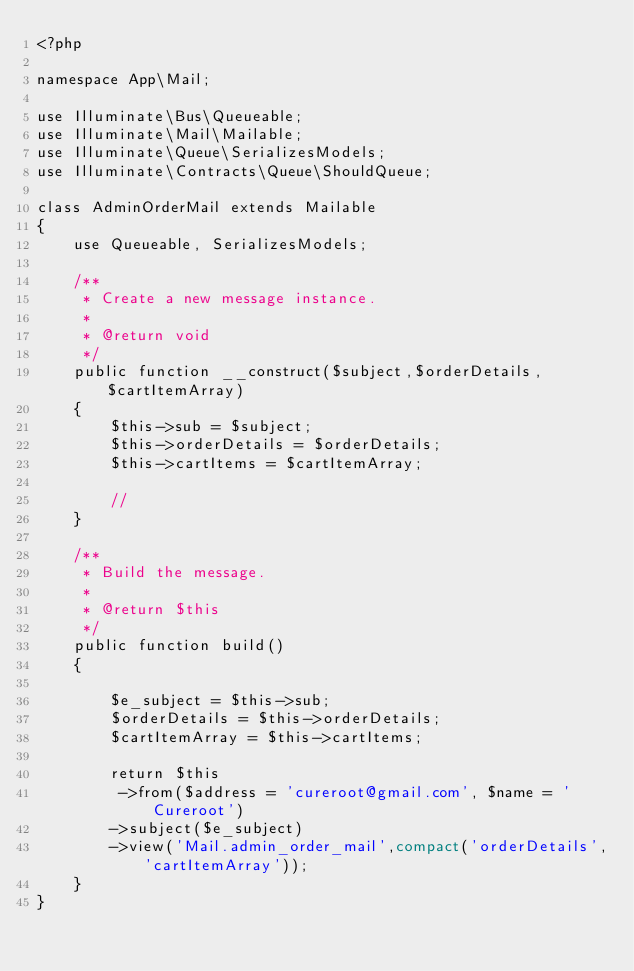Convert code to text. <code><loc_0><loc_0><loc_500><loc_500><_PHP_><?php

namespace App\Mail;

use Illuminate\Bus\Queueable;
use Illuminate\Mail\Mailable;
use Illuminate\Queue\SerializesModels;
use Illuminate\Contracts\Queue\ShouldQueue;

class AdminOrderMail extends Mailable
{
    use Queueable, SerializesModels;

    /**
     * Create a new message instance.
     *
     * @return void
     */
    public function __construct($subject,$orderDetails,$cartItemArray)
    {
        $this->sub = $subject;
        $this->orderDetails = $orderDetails;
        $this->cartItems = $cartItemArray;

        //
    }

    /**
     * Build the message.
     *
     * @return $this
     */
    public function build()
    {
        
        $e_subject = $this->sub;
        $orderDetails = $this->orderDetails;
        $cartItemArray = $this->cartItems;
        
        return $this
         ->from($address = 'cureroot@gmail.com', $name = 'Cureroot')
        ->subject($e_subject)
        ->view('Mail.admin_order_mail',compact('orderDetails','cartItemArray'));
    }
}
</code> 